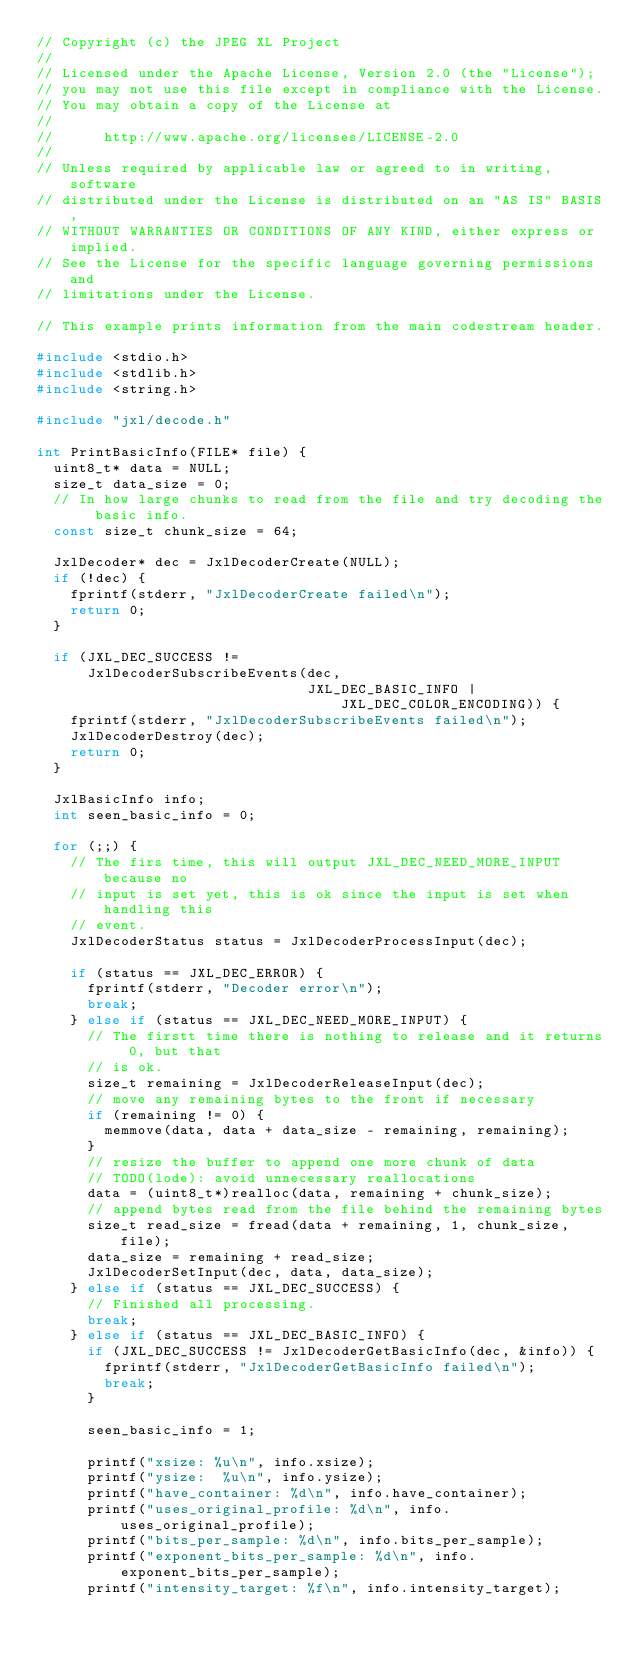<code> <loc_0><loc_0><loc_500><loc_500><_C_>// Copyright (c) the JPEG XL Project
//
// Licensed under the Apache License, Version 2.0 (the "License");
// you may not use this file except in compliance with the License.
// You may obtain a copy of the License at
//
//      http://www.apache.org/licenses/LICENSE-2.0
//
// Unless required by applicable law or agreed to in writing, software
// distributed under the License is distributed on an "AS IS" BASIS,
// WITHOUT WARRANTIES OR CONDITIONS OF ANY KIND, either express or implied.
// See the License for the specific language governing permissions and
// limitations under the License.

// This example prints information from the main codestream header.

#include <stdio.h>
#include <stdlib.h>
#include <string.h>

#include "jxl/decode.h"

int PrintBasicInfo(FILE* file) {
  uint8_t* data = NULL;
  size_t data_size = 0;
  // In how large chunks to read from the file and try decoding the basic info.
  const size_t chunk_size = 64;

  JxlDecoder* dec = JxlDecoderCreate(NULL);
  if (!dec) {
    fprintf(stderr, "JxlDecoderCreate failed\n");
    return 0;
  }

  if (JXL_DEC_SUCCESS !=
      JxlDecoderSubscribeEvents(dec,
                                JXL_DEC_BASIC_INFO | JXL_DEC_COLOR_ENCODING)) {
    fprintf(stderr, "JxlDecoderSubscribeEvents failed\n");
    JxlDecoderDestroy(dec);
    return 0;
  }

  JxlBasicInfo info;
  int seen_basic_info = 0;

  for (;;) {
    // The firs time, this will output JXL_DEC_NEED_MORE_INPUT because no
    // input is set yet, this is ok since the input is set when handling this
    // event.
    JxlDecoderStatus status = JxlDecoderProcessInput(dec);

    if (status == JXL_DEC_ERROR) {
      fprintf(stderr, "Decoder error\n");
      break;
    } else if (status == JXL_DEC_NEED_MORE_INPUT) {
      // The firstt time there is nothing to release and it returns 0, but that
      // is ok.
      size_t remaining = JxlDecoderReleaseInput(dec);
      // move any remaining bytes to the front if necessary
      if (remaining != 0) {
        memmove(data, data + data_size - remaining, remaining);
      }
      // resize the buffer to append one more chunk of data
      // TODO(lode): avoid unnecessary reallocations
      data = (uint8_t*)realloc(data, remaining + chunk_size);
      // append bytes read from the file behind the remaining bytes
      size_t read_size = fread(data + remaining, 1, chunk_size, file);
      data_size = remaining + read_size;
      JxlDecoderSetInput(dec, data, data_size);
    } else if (status == JXL_DEC_SUCCESS) {
      // Finished all processing.
      break;
    } else if (status == JXL_DEC_BASIC_INFO) {
      if (JXL_DEC_SUCCESS != JxlDecoderGetBasicInfo(dec, &info)) {
        fprintf(stderr, "JxlDecoderGetBasicInfo failed\n");
        break;
      }

      seen_basic_info = 1;

      printf("xsize: %u\n", info.xsize);
      printf("ysize:  %u\n", info.ysize);
      printf("have_container: %d\n", info.have_container);
      printf("uses_original_profile: %d\n", info.uses_original_profile);
      printf("bits_per_sample: %d\n", info.bits_per_sample);
      printf("exponent_bits_per_sample: %d\n", info.exponent_bits_per_sample);
      printf("intensity_target: %f\n", info.intensity_target);</code> 